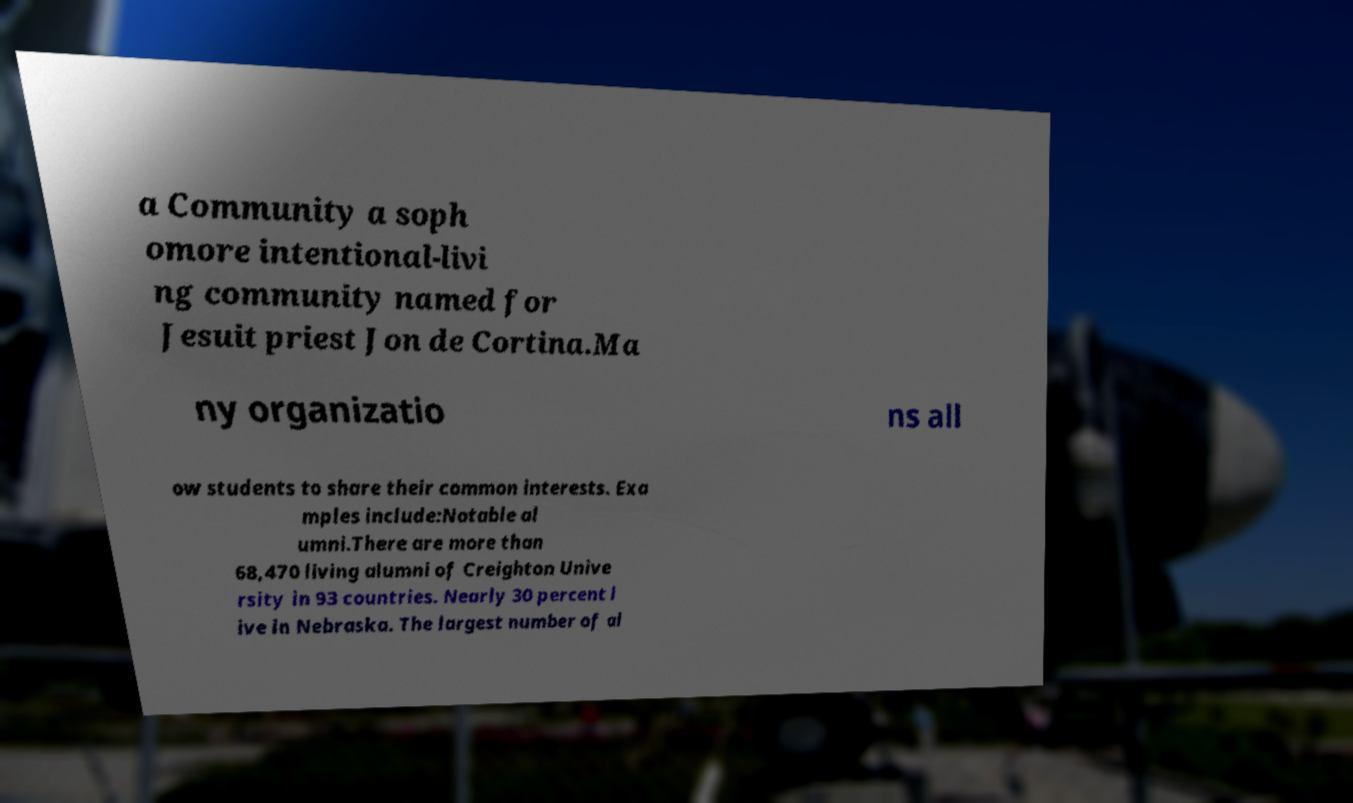Could you extract and type out the text from this image? a Community a soph omore intentional-livi ng community named for Jesuit priest Jon de Cortina.Ma ny organizatio ns all ow students to share their common interests. Exa mples include:Notable al umni.There are more than 68,470 living alumni of Creighton Unive rsity in 93 countries. Nearly 30 percent l ive in Nebraska. The largest number of al 